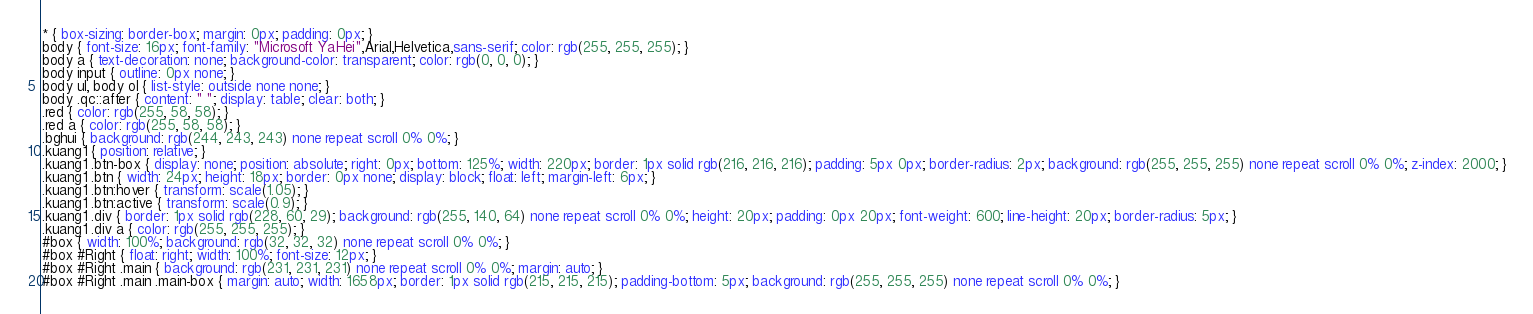<code> <loc_0><loc_0><loc_500><loc_500><_CSS_>
* { box-sizing: border-box; margin: 0px; padding: 0px; }
body { font-size: 16px; font-family: "Microsoft YaHei",Arial,Helvetica,sans-serif; color: rgb(255, 255, 255); }
body a { text-decoration: none; background-color: transparent; color: rgb(0, 0, 0); }
body input { outline: 0px none; }
body ul, body ol { list-style: outside none none; }
body .qc::after { content: " "; display: table; clear: both; }
.red { color: rgb(255, 58, 58); }
.red a { color: rgb(255, 58, 58); }
.bghui { background: rgb(244, 243, 243) none repeat scroll 0% 0%; }
.kuang1 { position: relative; }
.kuang1 .btn-box { display: none; position: absolute; right: 0px; bottom: 125%; width: 220px; border: 1px solid rgb(216, 216, 216); padding: 5px 0px; border-radius: 2px; background: rgb(255, 255, 255) none repeat scroll 0% 0%; z-index: 2000; }
.kuang1 .btn { width: 24px; height: 18px; border: 0px none; display: block; float: left; margin-left: 6px; }
.kuang1 .btn:hover { transform: scale(1.05); }
.kuang1 .btn:active { transform: scale(0.9); }
.kuang1 .div { border: 1px solid rgb(228, 60, 29); background: rgb(255, 140, 64) none repeat scroll 0% 0%; height: 20px; padding: 0px 20px; font-weight: 600; line-height: 20px; border-radius: 5px; }
.kuang1 .div a { color: rgb(255, 255, 255); }
#box { width: 100%; background: rgb(32, 32, 32) none repeat scroll 0% 0%; }
#box #Right { float: right; width: 100%; font-size: 12px; }
#box #Right .main { background: rgb(231, 231, 231) none repeat scroll 0% 0%; margin: auto; }
#box #Right .main .main-box { margin: auto; width: 1658px; border: 1px solid rgb(215, 215, 215); padding-bottom: 5px; background: rgb(255, 255, 255) none repeat scroll 0% 0%; }</code> 